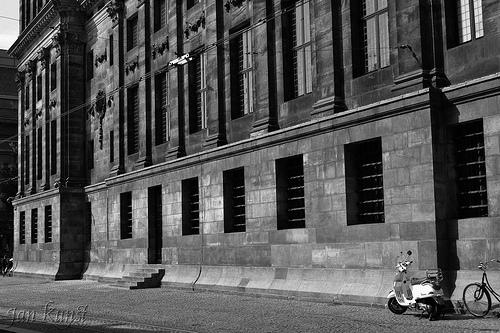Mention the key elements of the image in a minimalist style. Motorcycle, bicycle, sidewalk, old brick building, windows, stairs, doorway. Describe the details of the image using a casual tone. There's a cool motorcycle and a bike chillin' on the sidewalk next to this old brick building with lots of windows and some stairs leading up to a door. Describe the image as if writing a brief travel postcard. Greetings! Stumbled upon a charming old brick building with numerous windows, a motorcycle, and a bicycle parked outside. Wish you were here! Mention the objects in the image along with their location. Motorcycle on sidewalk, bicycle on sidewalk, stairs by the doorway, door in front of stairs, windows on building, large old brick building. Describe the image as if you were providing an audio description for the visually impaired. In the image, a large, aged brick building dominates the scene with multiple rows of windows. To the right of the building, a motorcycle and a bicycle are parked on the sidewalk, and a set of stairs lead up to a doorway. Explain the image as if describing it to a child. There's a picture of a big, old building made of bricks with lots of windows. Next to the building, there is a bicycle and a motorcycle on the sidewalk. Provide a brief description of the main focus of the image. A motorcycle and a bicycle are parked on a sidewalk beside a large old brick building with numerous windows and a doorway with stairs. List the distinctive features of the image in a poetic manner. Wheels resting by brick walls, windows whispering secrets, stairs that witness steps, a doorway opening memories. Provide a description for a news report about the image. In a quiet cityscape, an old brick building stands tall and proud, featuring several rows of windows, along with a parked motorcycle and a bicycle on the sidewalk nearby, indicating everyday life in the area. Summarize the image's contents in a single sentence. Motorcycle and bicycle parked by a brick building with various windows, stairs, and a doorway. 